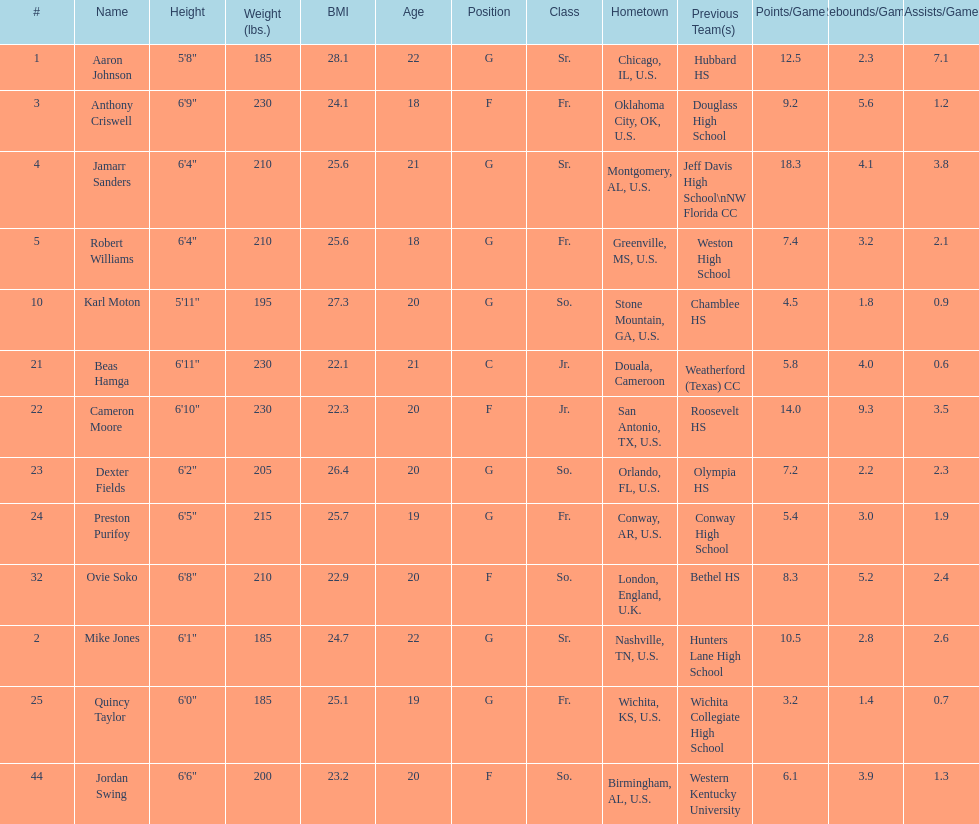Who is the tallest player on the team? Beas Hamga. 